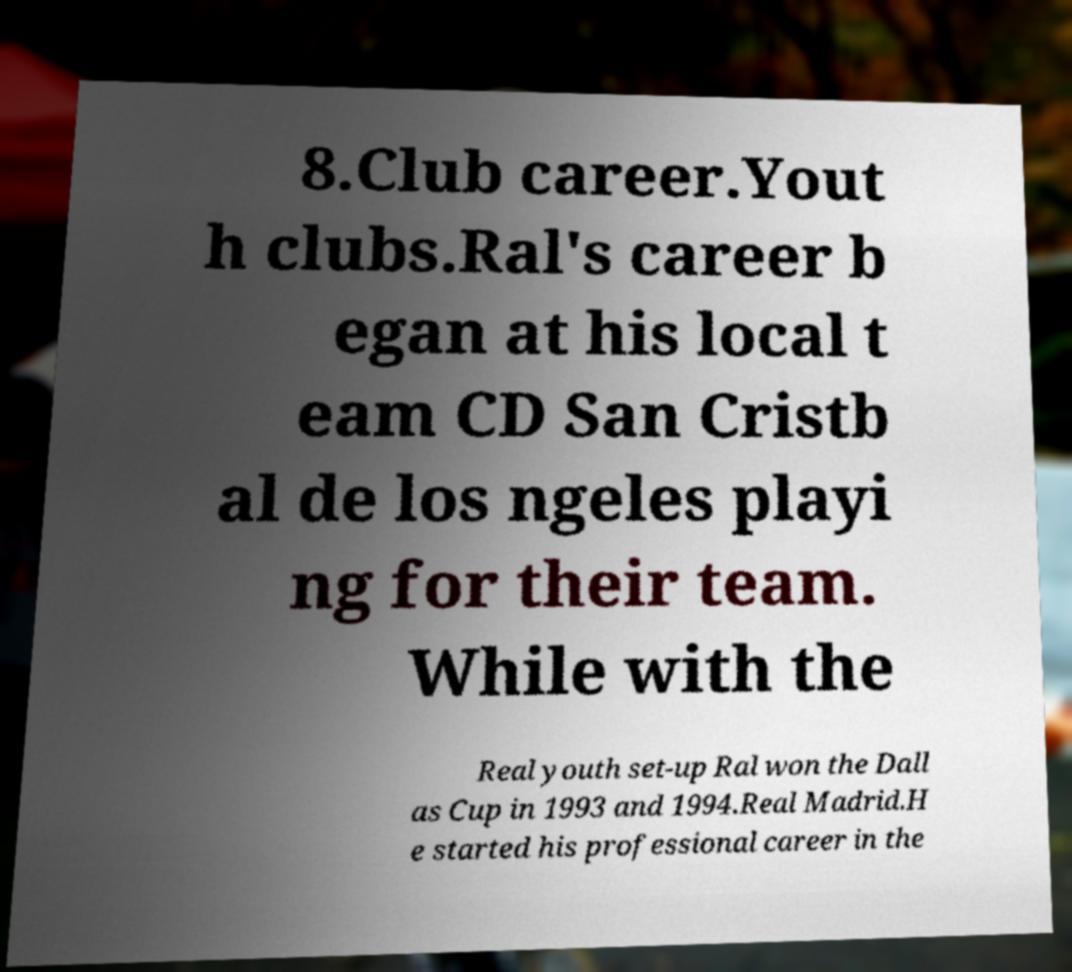Please read and relay the text visible in this image. What does it say? 8.Club career.Yout h clubs.Ral's career b egan at his local t eam CD San Cristb al de los ngeles playi ng for their team. While with the Real youth set-up Ral won the Dall as Cup in 1993 and 1994.Real Madrid.H e started his professional career in the 